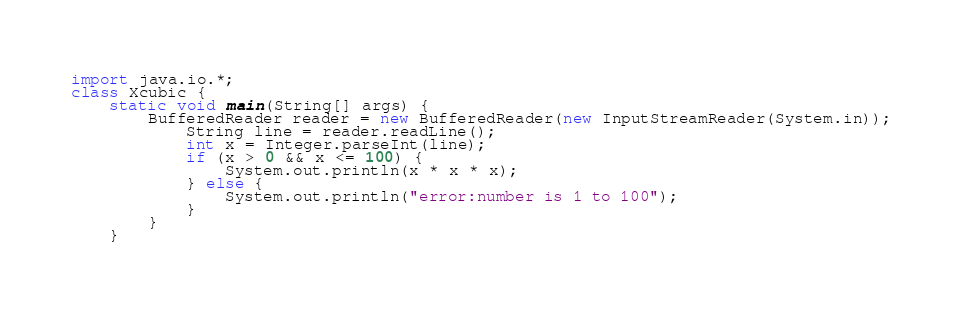<code> <loc_0><loc_0><loc_500><loc_500><_Java_>import java.io.*;
class Xcubic {
	static void main(String[] args) {
		BufferedReader reader = new BufferedReader(new InputStreamReader(System.in));
        	String line = reader.readLine();
        	int x = Integer.parseInt(line);
        	if (x > 0 && x <= 100) {
        		System.out.println(x * x * x);
        	} else {
        		System.out.println("error:number is 1 to 100");
        	}
        }
    }</code> 